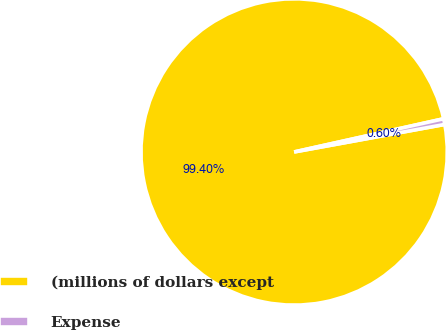Convert chart. <chart><loc_0><loc_0><loc_500><loc_500><pie_chart><fcel>(millions of dollars except<fcel>Expense<nl><fcel>99.4%<fcel>0.6%<nl></chart> 